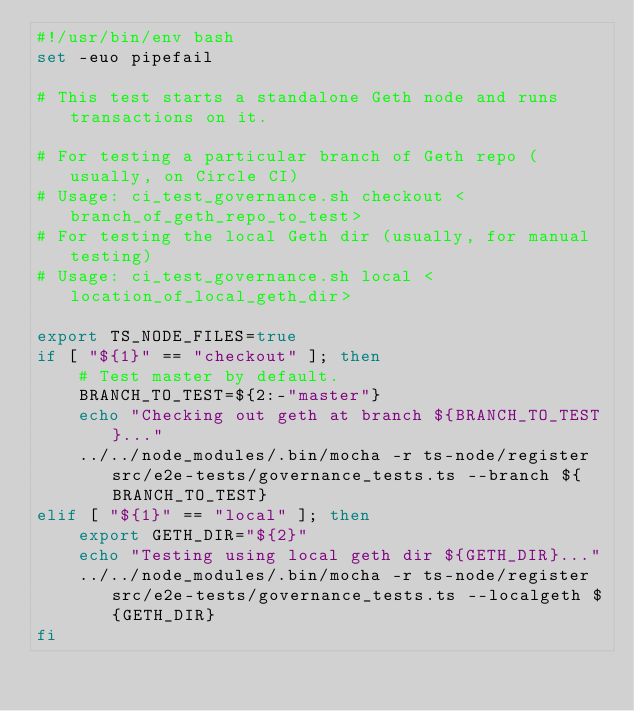Convert code to text. <code><loc_0><loc_0><loc_500><loc_500><_Bash_>#!/usr/bin/env bash
set -euo pipefail

# This test starts a standalone Geth node and runs transactions on it.

# For testing a particular branch of Geth repo (usually, on Circle CI)
# Usage: ci_test_governance.sh checkout <branch_of_geth_repo_to_test>
# For testing the local Geth dir (usually, for manual testing)
# Usage: ci_test_governance.sh local <location_of_local_geth_dir>

export TS_NODE_FILES=true
if [ "${1}" == "checkout" ]; then
    # Test master by default.
    BRANCH_TO_TEST=${2:-"master"}
    echo "Checking out geth at branch ${BRANCH_TO_TEST}..."
    ../../node_modules/.bin/mocha -r ts-node/register src/e2e-tests/governance_tests.ts --branch ${BRANCH_TO_TEST}
elif [ "${1}" == "local" ]; then
    export GETH_DIR="${2}"
    echo "Testing using local geth dir ${GETH_DIR}..."
    ../../node_modules/.bin/mocha -r ts-node/register src/e2e-tests/governance_tests.ts --localgeth ${GETH_DIR}
fi
</code> 